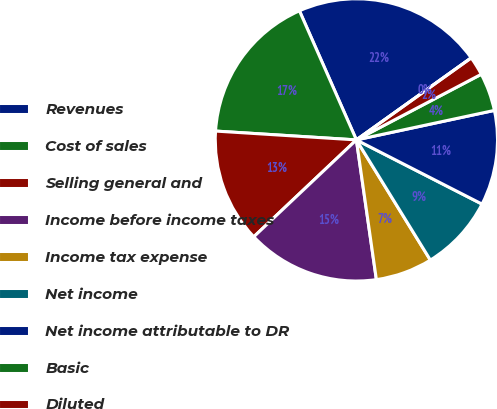Convert chart to OTSL. <chart><loc_0><loc_0><loc_500><loc_500><pie_chart><fcel>Revenues<fcel>Cost of sales<fcel>Selling general and<fcel>Income before income taxes<fcel>Income tax expense<fcel>Net income<fcel>Net income attributable to DR<fcel>Basic<fcel>Diluted<fcel>Cash dividends declared per<nl><fcel>21.74%<fcel>17.39%<fcel>13.04%<fcel>15.22%<fcel>6.52%<fcel>8.7%<fcel>10.87%<fcel>4.35%<fcel>2.17%<fcel>0.0%<nl></chart> 